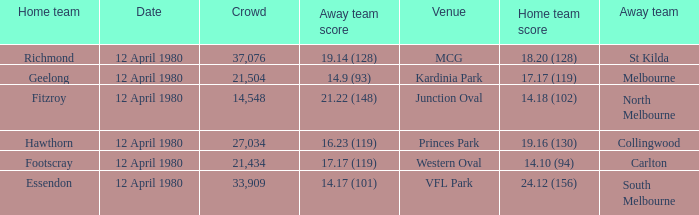Could you parse the entire table as a dict? {'header': ['Home team', 'Date', 'Crowd', 'Away team score', 'Venue', 'Home team score', 'Away team'], 'rows': [['Richmond', '12 April 1980', '37,076', '19.14 (128)', 'MCG', '18.20 (128)', 'St Kilda'], ['Geelong', '12 April 1980', '21,504', '14.9 (93)', 'Kardinia Park', '17.17 (119)', 'Melbourne'], ['Fitzroy', '12 April 1980', '14,548', '21.22 (148)', 'Junction Oval', '14.18 (102)', 'North Melbourne'], ['Hawthorn', '12 April 1980', '27,034', '16.23 (119)', 'Princes Park', '19.16 (130)', 'Collingwood'], ['Footscray', '12 April 1980', '21,434', '17.17 (119)', 'Western Oval', '14.10 (94)', 'Carlton'], ['Essendon', '12 April 1980', '33,909', '14.17 (101)', 'VFL Park', '24.12 (156)', 'South Melbourne']]} Where did fitzroy play as the home team? Junction Oval. 